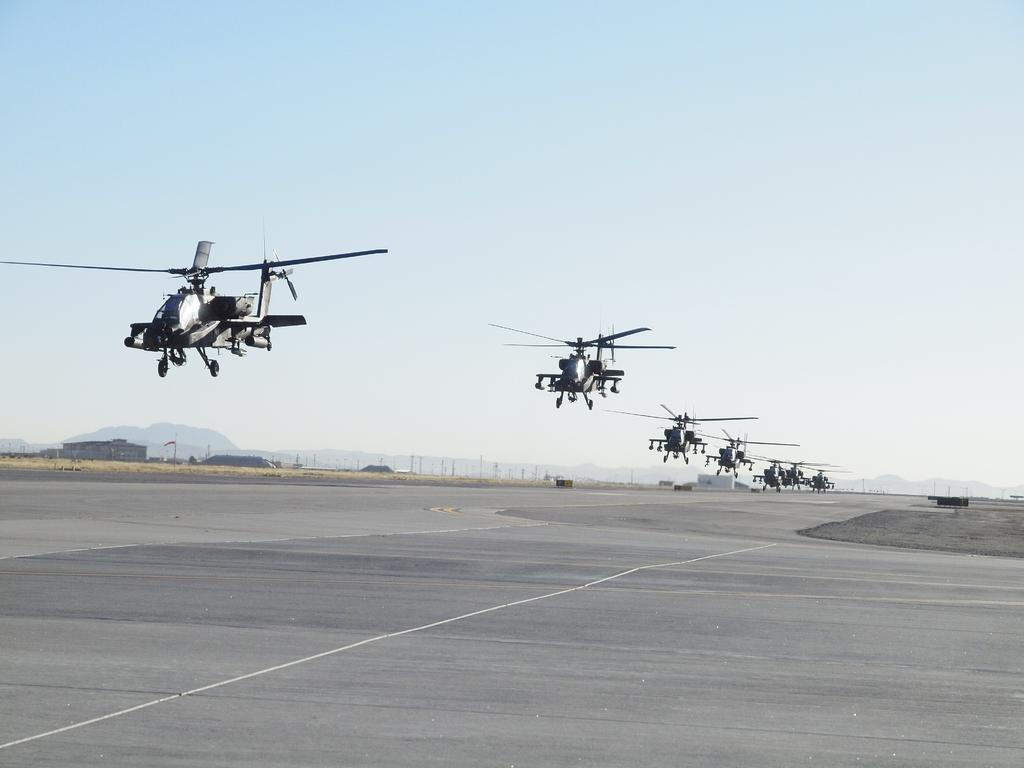What type of surface is visible in the image? There is a ground in the image. What type of vehicles are present in the image? There are helicopters in the image. What type of structures can be seen in the image? There are sheds in the image. What type of infrastructure is visible in the image? There are electric poles in the image. What can be seen in the distance in the image? There are mountains visible in the background of the image. What is visible above the ground in the image? The sky is visible in the background of the image. How much wealth is stored in the box in the image? There is no box present in the image, so it is not possible to determine the amount of wealth stored in it. 